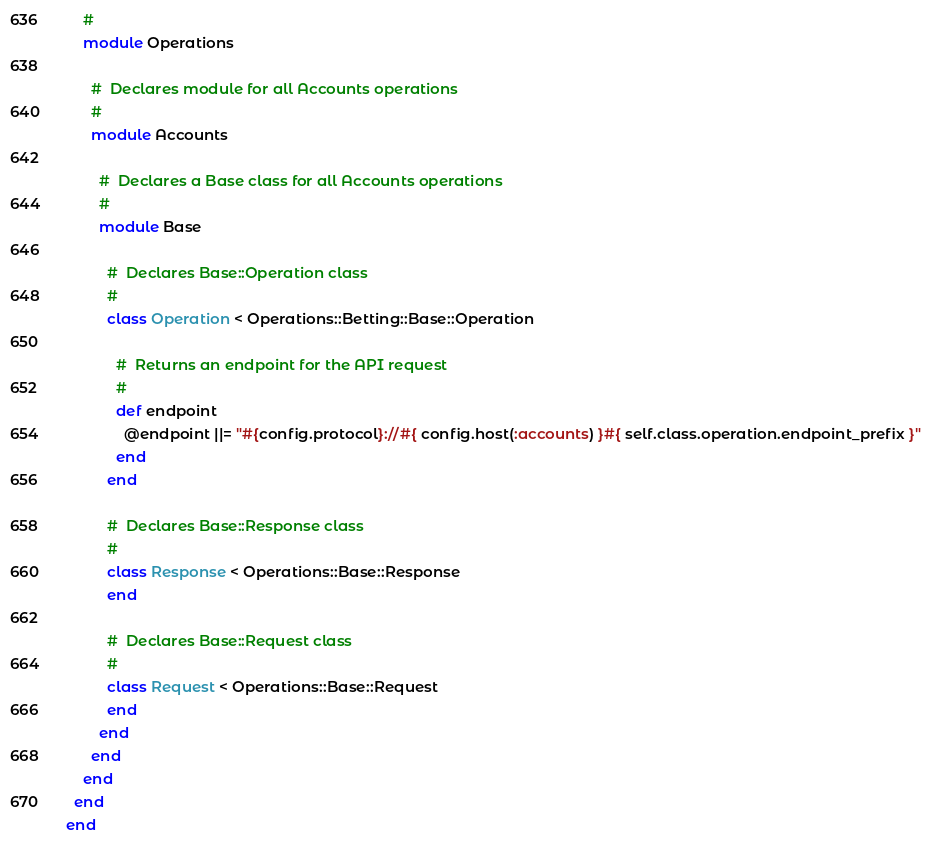Convert code to text. <code><loc_0><loc_0><loc_500><loc_500><_Ruby_>    #
    module Operations

      #  Declares module for all Accounts operations
      #
      module Accounts

        #  Declares a Base class for all Accounts operations
        #
        module Base

          #  Declares Base::Operation class
          #
          class Operation < Operations::Betting::Base::Operation

            #  Returns an endpoint for the API request
            #
            def endpoint
              @endpoint ||= "#{config.protocol}://#{ config.host(:accounts) }#{ self.class.operation.endpoint_prefix }"
            end
          end

          #  Declares Base::Response class
          #
          class Response < Operations::Base::Response
          end

          #  Declares Base::Request class
          #
          class Request < Operations::Base::Request
          end
        end
      end
    end
  end
end
</code> 